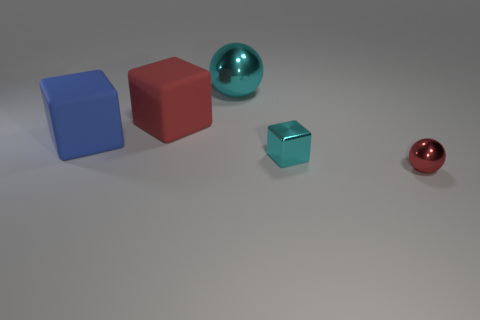Add 3 cyan objects. How many objects exist? 8 Subtract all blocks. How many objects are left? 2 Subtract 1 red spheres. How many objects are left? 4 Subtract all shiny blocks. Subtract all red rubber blocks. How many objects are left? 3 Add 1 balls. How many balls are left? 3 Add 5 large rubber cylinders. How many large rubber cylinders exist? 5 